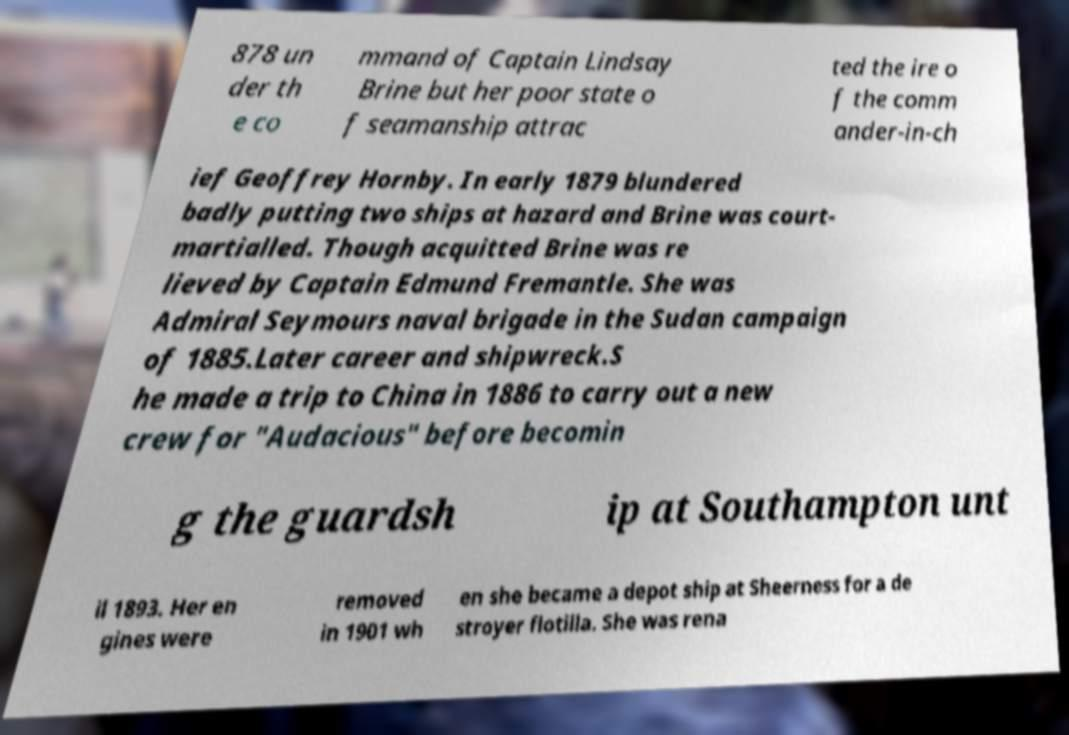For documentation purposes, I need the text within this image transcribed. Could you provide that? 878 un der th e co mmand of Captain Lindsay Brine but her poor state o f seamanship attrac ted the ire o f the comm ander-in-ch ief Geoffrey Hornby. In early 1879 blundered badly putting two ships at hazard and Brine was court- martialled. Though acquitted Brine was re lieved by Captain Edmund Fremantle. She was Admiral Seymours naval brigade in the Sudan campaign of 1885.Later career and shipwreck.S he made a trip to China in 1886 to carry out a new crew for "Audacious" before becomin g the guardsh ip at Southampton unt il 1893. Her en gines were removed in 1901 wh en she became a depot ship at Sheerness for a de stroyer flotilla. She was rena 